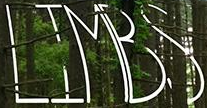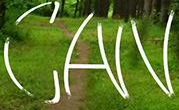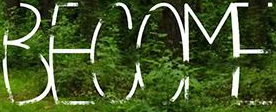What words can you see in these images in sequence, separated by a semicolon? LIMBS; CAN; BECOME 